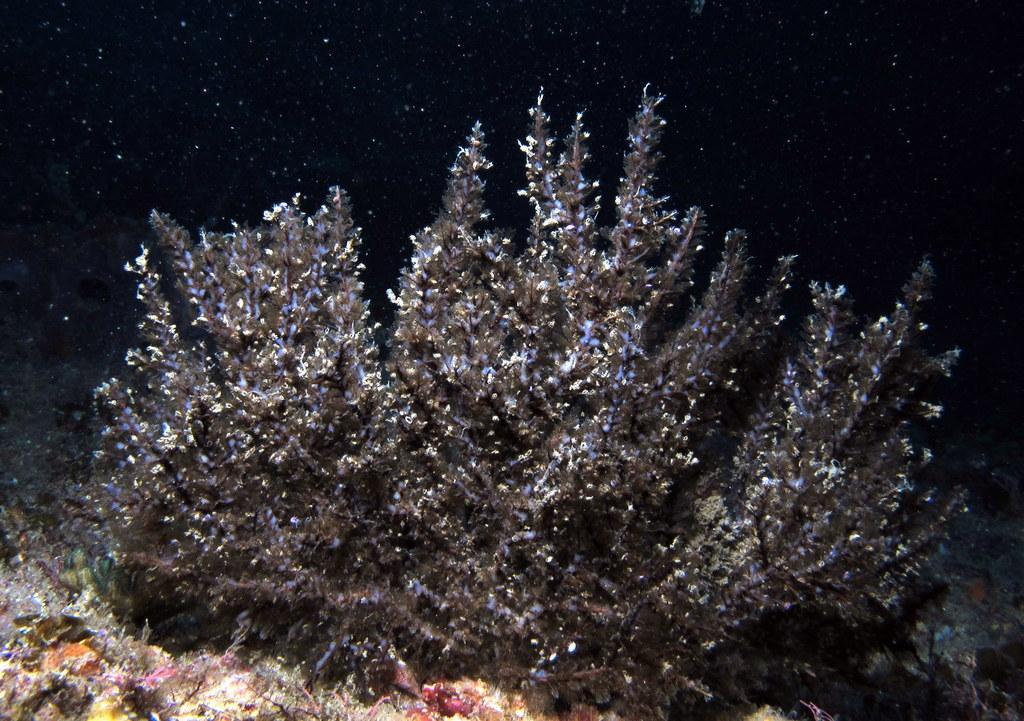Please provide a concise description of this image. In the picture I can see plant, grass. 